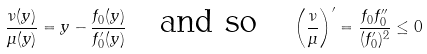Convert formula to latex. <formula><loc_0><loc_0><loc_500><loc_500>\frac { \nu ( y ) } { \mu ( y ) } = y - \frac { f _ { 0 } ( y ) } { f _ { 0 } ^ { \prime } ( y ) } \quad \text {and so} \quad \left ( \frac { \nu } { \mu } \right ) ^ { \prime } = \frac { f _ { 0 } f _ { 0 } ^ { \prime \prime } } { ( f _ { 0 } ^ { \prime } ) ^ { 2 } } \leq 0</formula> 